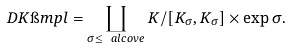Convert formula to latex. <formula><loc_0><loc_0><loc_500><loc_500>D K \i m p l = \coprod _ { \sigma \leq \ a l c o v e } K / [ K _ { \sigma } , K _ { \sigma } ] \times \exp \sigma .</formula> 